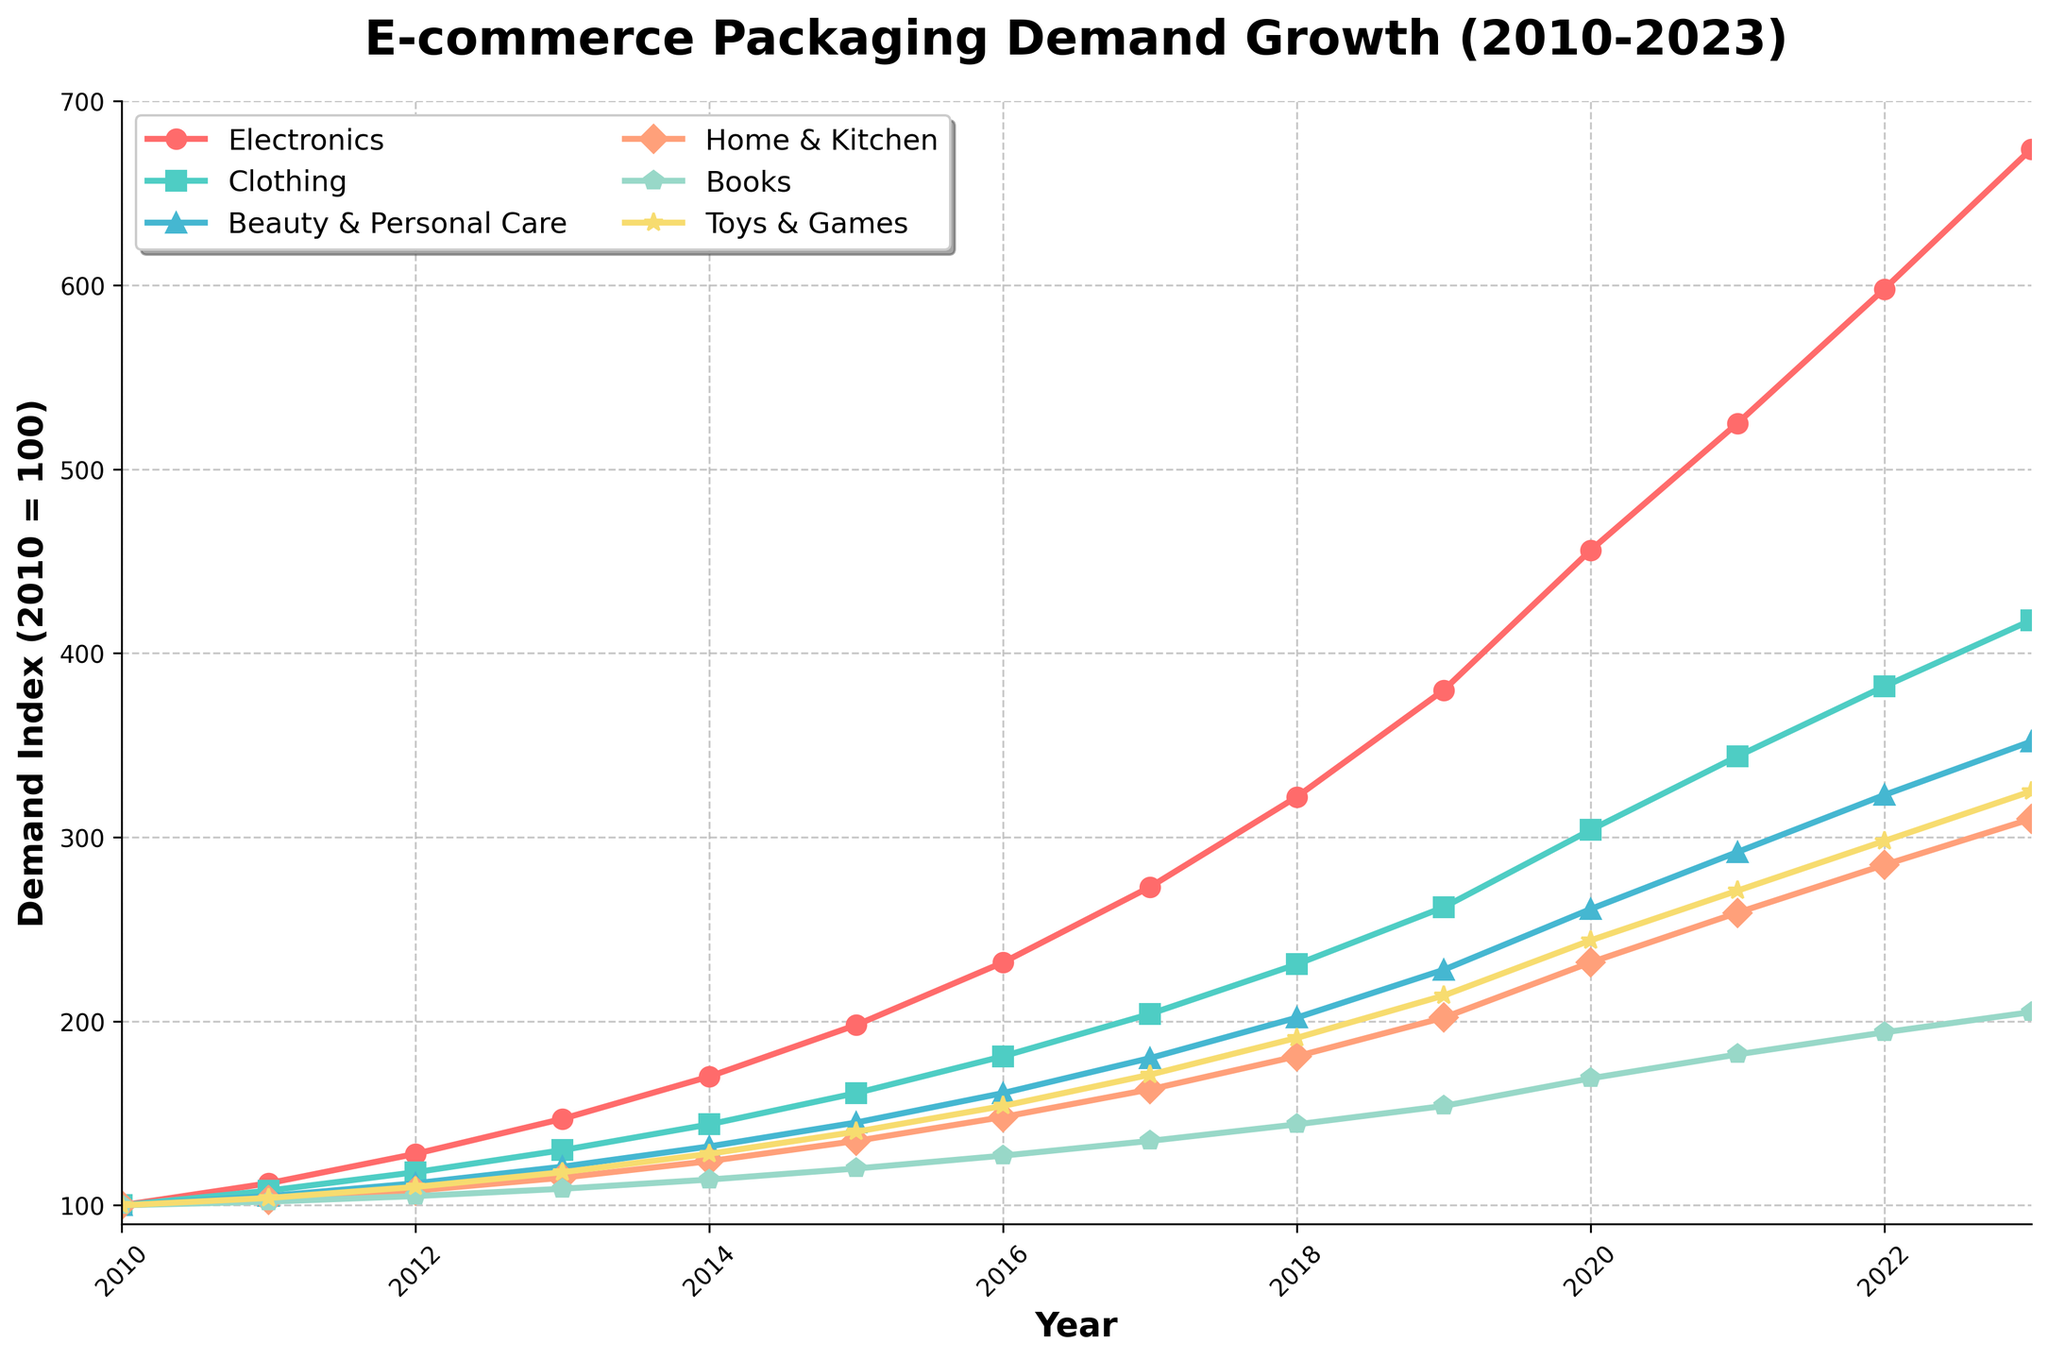Comparing the rise in Electronics and Beauty & Personal Care, how much higher is Electronics in 2023? Look at the 2023 points for both categories. Electronics has a demand index of 674, while Beauty & Personal Care has 352. The difference between them is calculated as 674 - 352.
Answer: 322 Which product category experienced the most significant growth between 2010 and 2023? Compare the growth of all categories from 2010 to 2023. Electronics starts at 100 and ends at 674, which is a growth of 674 - 100 = 574. No other category shows higher growth than this.
Answer: Electronics For which years did Clothing demand index surpass 300? Look at the Clothing demand index on the y-axis and identify the years when the index passed above 300. Clothing surpasses 300 from 2020 onwards.
Answer: 2020, 2021, 2022, 2023 What is the average demand index for Toys & Games from 2019 to 2023? Calculate the average of the demand indices for Toys & Games from 2019 to 2023 by adding the values for these years and then dividing by the number of years: (214 + 244 + 271 + 298 + 325) / 5. This results in (214 + 244 + 271 + 298 + 325) / 5 = 1352 / 5 = 270.4.
Answer: 270.4 Which product category’s demand showed the least variation over the period from 2010 to 2023? Determine the variability by looking at the height of the lines. Smaller variability is indicated by a smaller range between the 2010 to 2023 values. Books has the smallest change, from 100 to 205, resulting in a difference of 205 - 100 = 105.
Answer: Books In which year did Electronics demand index first exceed 300? Identify the year when Electronics demand surpasses the 300-mark on the y-axis. This happened in 2018.
Answer: 2018 Was the growth rate for Home & Kitchen more consistent than the growth for Toys & Games between 2010 and 2023? Examine the line shapes for Home & Kitchen and Toys & Games. Home & Kitchen shows a smoother trajectory without sharp increases or dips, indicating more consistent growth compared to Toys & Games, which has sharper increases especially after 2019.
Answer: Yes By how much did the demand for Beauty & Personal Care increase from 2020 to 2023? Look at the demand index values for Beauty & Personal Care in these years: it was 261 in 2020 and 352 in 2023. Calculate the increase by subtracting the 2020 value from the 2023 value: 352 - 261 = 91.
Answer: 91 